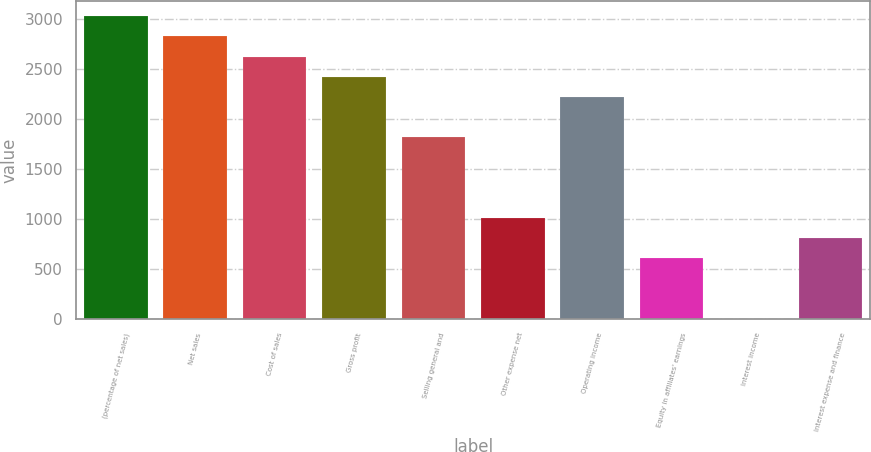Convert chart to OTSL. <chart><loc_0><loc_0><loc_500><loc_500><bar_chart><fcel>(percentage of net sales)<fcel>Net sales<fcel>Cost of sales<fcel>Gross profit<fcel>Selling general and<fcel>Other expense net<fcel>Operating income<fcel>Equity in affiliates' earnings<fcel>Interest income<fcel>Interest expense and finance<nl><fcel>3023.95<fcel>2822.36<fcel>2620.77<fcel>2419.18<fcel>1814.41<fcel>1008.05<fcel>2217.59<fcel>604.87<fcel>0.1<fcel>806.46<nl></chart> 